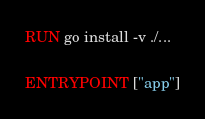Convert code to text. <code><loc_0><loc_0><loc_500><loc_500><_Dockerfile_>
RUN go install -v ./...

ENTRYPOINT ["app"]

</code> 